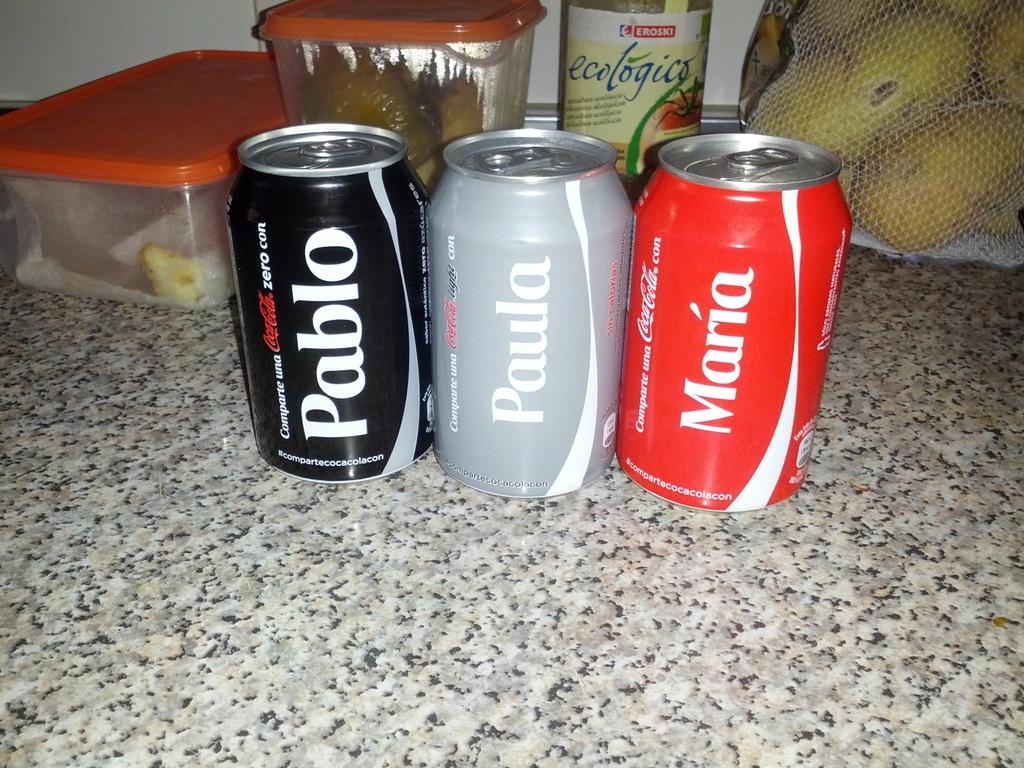Provide a one-sentence caption for the provided image. Three personalized coke cans with the names Pablo, Monica and Paula printed on them. 